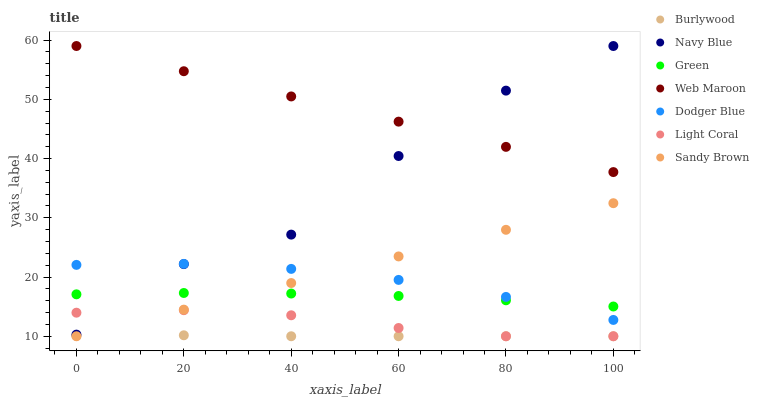Does Burlywood have the minimum area under the curve?
Answer yes or no. Yes. Does Web Maroon have the maximum area under the curve?
Answer yes or no. Yes. Does Navy Blue have the minimum area under the curve?
Answer yes or no. No. Does Navy Blue have the maximum area under the curve?
Answer yes or no. No. Is Sandy Brown the smoothest?
Answer yes or no. Yes. Is Navy Blue the roughest?
Answer yes or no. Yes. Is Web Maroon the smoothest?
Answer yes or no. No. Is Web Maroon the roughest?
Answer yes or no. No. Does Burlywood have the lowest value?
Answer yes or no. Yes. Does Navy Blue have the lowest value?
Answer yes or no. No. Does Web Maroon have the highest value?
Answer yes or no. Yes. Does Light Coral have the highest value?
Answer yes or no. No. Is Sandy Brown less than Web Maroon?
Answer yes or no. Yes. Is Green greater than Burlywood?
Answer yes or no. Yes. Does Navy Blue intersect Web Maroon?
Answer yes or no. Yes. Is Navy Blue less than Web Maroon?
Answer yes or no. No. Is Navy Blue greater than Web Maroon?
Answer yes or no. No. Does Sandy Brown intersect Web Maroon?
Answer yes or no. No. 